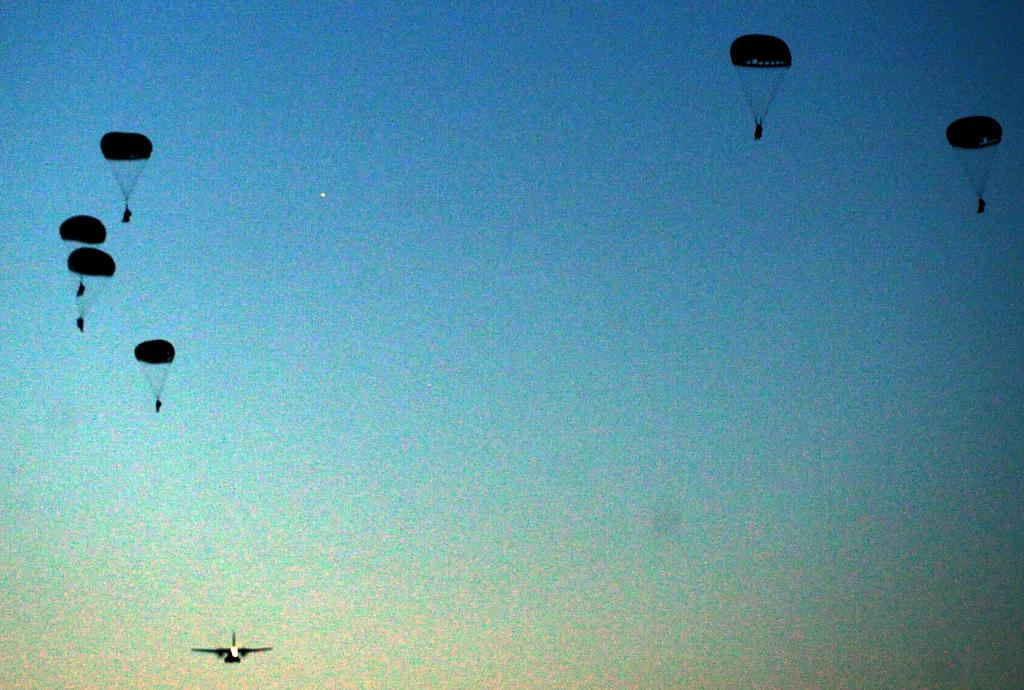What is happening in the image involving parachutes? There are parachutes flying in the image. Can you identify any other objects or subjects in the image? Yes, there is an airplane in the image. What type of beetle can be seen crawling on the comb in the image? There is no beetle or comb present in the image; it features parachutes flying and an airplane. How many twigs are visible in the image? There are no twigs present in the image. 